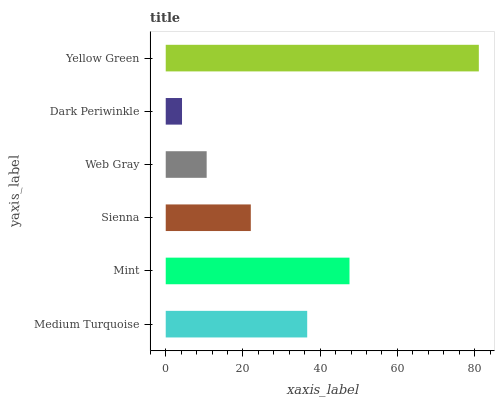Is Dark Periwinkle the minimum?
Answer yes or no. Yes. Is Yellow Green the maximum?
Answer yes or no. Yes. Is Mint the minimum?
Answer yes or no. No. Is Mint the maximum?
Answer yes or no. No. Is Mint greater than Medium Turquoise?
Answer yes or no. Yes. Is Medium Turquoise less than Mint?
Answer yes or no. Yes. Is Medium Turquoise greater than Mint?
Answer yes or no. No. Is Mint less than Medium Turquoise?
Answer yes or no. No. Is Medium Turquoise the high median?
Answer yes or no. Yes. Is Sienna the low median?
Answer yes or no. Yes. Is Dark Periwinkle the high median?
Answer yes or no. No. Is Mint the low median?
Answer yes or no. No. 